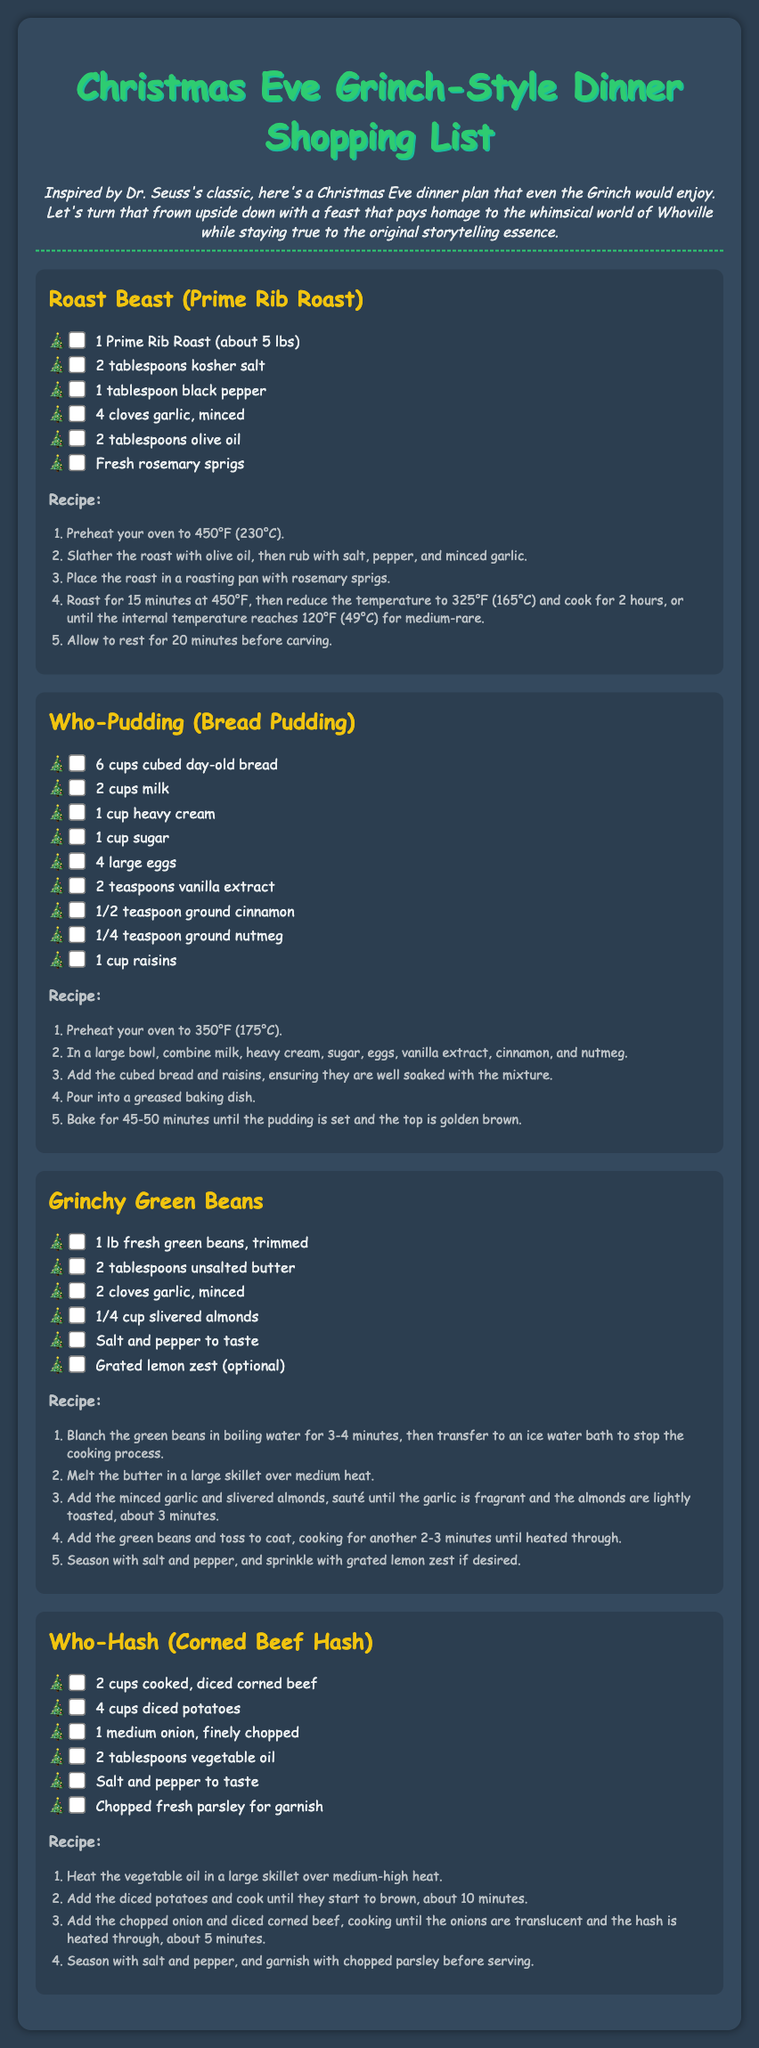What is the main dish in the dinner plan? The main dish is highlighted in the document as "Roast Beast (Prime Rib Roast)."
Answer: Roast Beast (Prime Rib Roast) How many cups of cubed bread are needed for Who-Pudding? The document lists the ingredients for Who-Pudding, specifying the need for 6 cups of cubed day-old bread.
Answer: 6 cups What type of beans are used in the Grinchy dish? The document describes the dish "Grinchy Green Beans," indicating the specific type of beans used.
Answer: Green beans How many tablespoons of butter are required for the Grinchy Green Beans? The ingredient list for Grinchy Green Beans clearly states that 2 tablespoons of unsalted butter are needed.
Answer: 2 tablespoons What is the cooking temperature for the Roast Beast? The document states the required cooking temperature, which starts at 450°F for the initial roasting of the meat.
Answer: 450°F What is the optional ingredient in the Grinchy Green Beans recipe? The recipe mentions grated lemon zest as an optional ingredient, which is highlighted in the ingredients list.
Answer: Grated lemon zest How long should the Who-Pudding bake? The baking time for Who-Pudding is specified as 45-50 minutes in the recipe.
Answer: 45-50 minutes What must be done to the green beans before cooking? The recipe instructs to blanch the green beans in boiling water for 3-4 minutes before further cooking.
Answer: Blanch in boiling water What garnish is mentioned for Who-Hash? The ingredient list for Who-Hash includes chopped fresh parsley for garnish, indicating its role as a finishing touch.
Answer: Chopped fresh parsley 